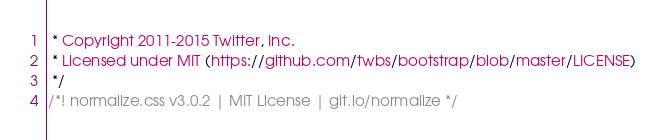Convert code to text. <code><loc_0><loc_0><loc_500><loc_500><_CSS_> * Copyright 2011-2015 Twitter, Inc.
 * Licensed under MIT (https://github.com/twbs/bootstrap/blob/master/LICENSE)
 */
/*! normalize.css v3.0.2 | MIT License | git.io/normalize */</code> 